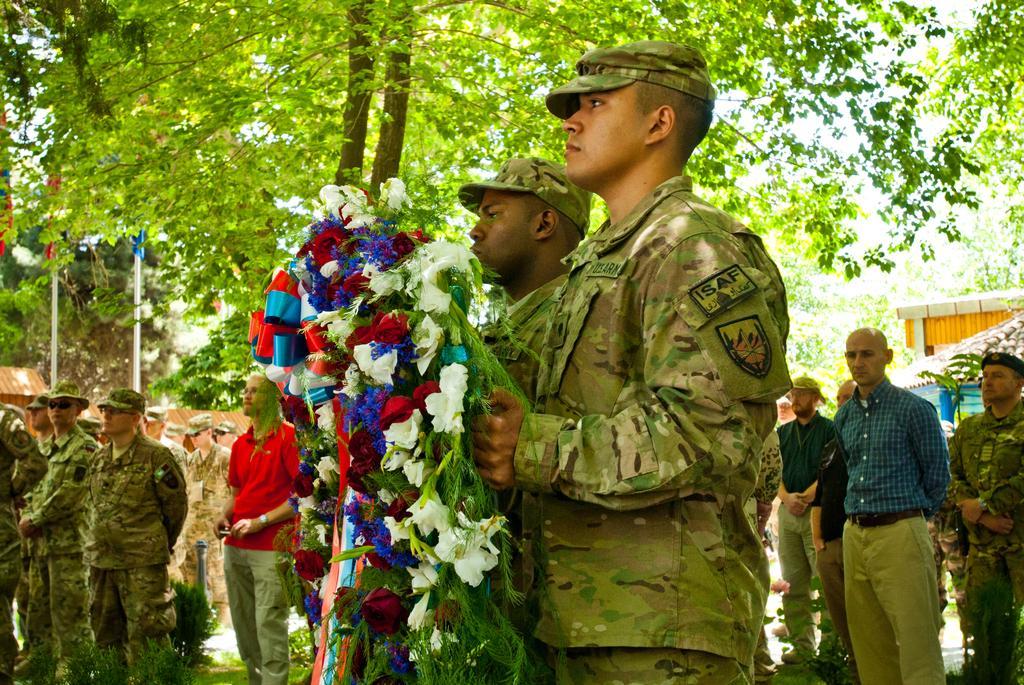Could you give a brief overview of what you see in this image? In this picture there are people standing, among them there's a man holding a bouquet. We can see planets, houses, rooftops, grass, trees and flagpoles. In the background of the image we can see the sky. 